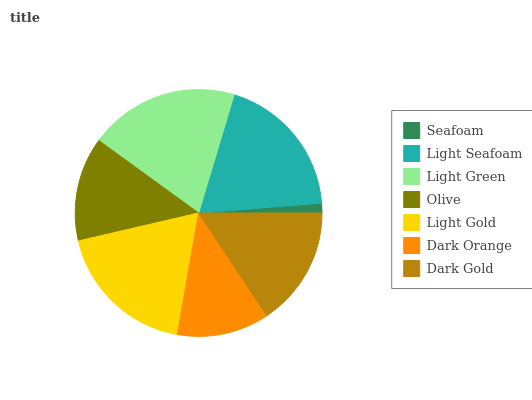Is Seafoam the minimum?
Answer yes or no. Yes. Is Light Green the maximum?
Answer yes or no. Yes. Is Light Seafoam the minimum?
Answer yes or no. No. Is Light Seafoam the maximum?
Answer yes or no. No. Is Light Seafoam greater than Seafoam?
Answer yes or no. Yes. Is Seafoam less than Light Seafoam?
Answer yes or no. Yes. Is Seafoam greater than Light Seafoam?
Answer yes or no. No. Is Light Seafoam less than Seafoam?
Answer yes or no. No. Is Dark Gold the high median?
Answer yes or no. Yes. Is Dark Gold the low median?
Answer yes or no. Yes. Is Light Seafoam the high median?
Answer yes or no. No. Is Olive the low median?
Answer yes or no. No. 